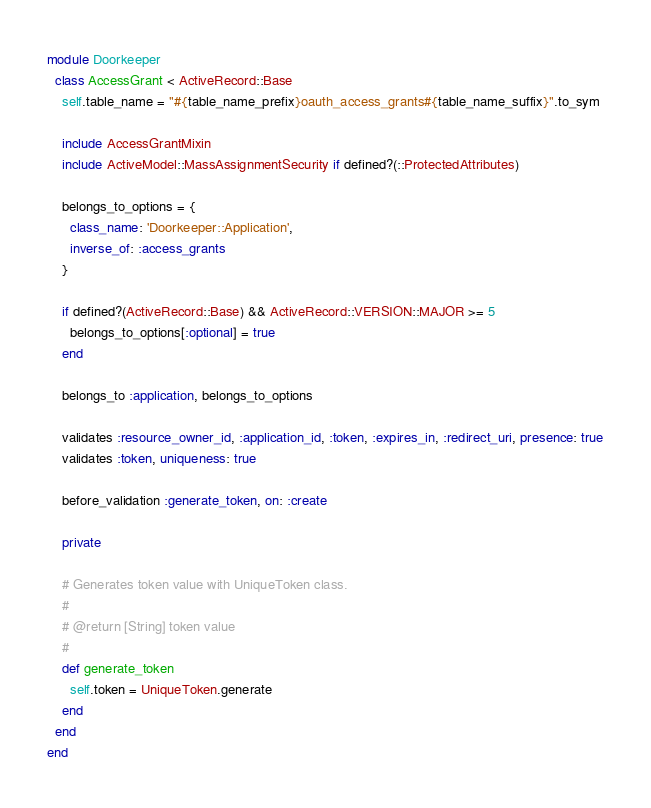<code> <loc_0><loc_0><loc_500><loc_500><_Ruby_>module Doorkeeper
  class AccessGrant < ActiveRecord::Base
    self.table_name = "#{table_name_prefix}oauth_access_grants#{table_name_suffix}".to_sym

    include AccessGrantMixin
    include ActiveModel::MassAssignmentSecurity if defined?(::ProtectedAttributes)

    belongs_to_options = {
      class_name: 'Doorkeeper::Application',
      inverse_of: :access_grants
    }

    if defined?(ActiveRecord::Base) && ActiveRecord::VERSION::MAJOR >= 5
      belongs_to_options[:optional] = true
    end

    belongs_to :application, belongs_to_options

    validates :resource_owner_id, :application_id, :token, :expires_in, :redirect_uri, presence: true
    validates :token, uniqueness: true

    before_validation :generate_token, on: :create

    private

    # Generates token value with UniqueToken class.
    #
    # @return [String] token value
    #
    def generate_token
      self.token = UniqueToken.generate
    end
  end
end
</code> 